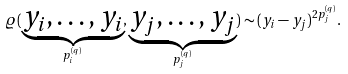<formula> <loc_0><loc_0><loc_500><loc_500>\varrho ( \underbrace { y _ { i } , \dots , y _ { i } } _ { p _ { i } ^ { ( q ) } } , \underbrace { y _ { j } , \dots , y _ { j } } _ { p _ { j } ^ { ( q ) } } ) \sim ( y _ { i } - y _ { j } ) ^ { 2 p _ { j } ^ { ( q ) } } .</formula> 